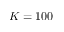Convert formula to latex. <formula><loc_0><loc_0><loc_500><loc_500>K = 1 0 0</formula> 